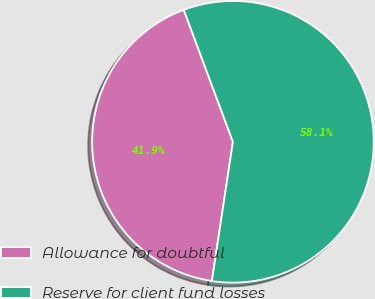<chart> <loc_0><loc_0><loc_500><loc_500><pie_chart><fcel>Allowance for doubtful<fcel>Reserve for client fund losses<nl><fcel>41.94%<fcel>58.06%<nl></chart> 